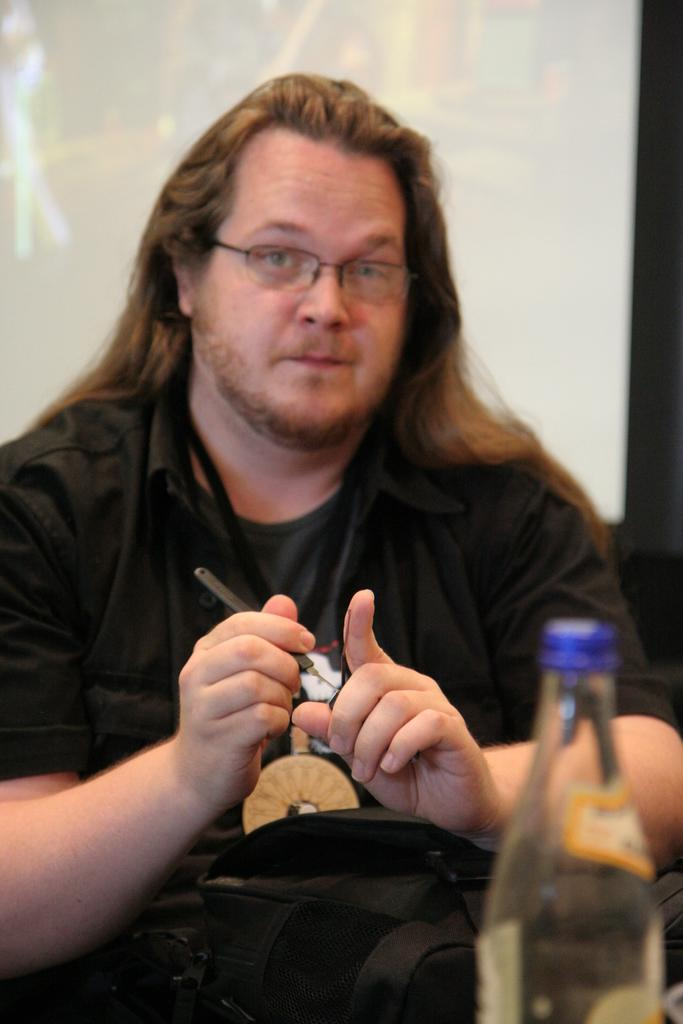Who is present in the image? There is a man in the image. What is the man wearing? The man is wearing a black shirt. What is the man holding in his hands? The man is holding something in his hands. What other objects can be seen in the image? There is a bag and a bottle in the image. What type of plant is the man teaching in the image? There is no plant or class present in the image; it only features a man holding something, a bag, and a bottle. 